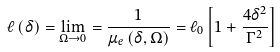Convert formula to latex. <formula><loc_0><loc_0><loc_500><loc_500>\ell \left ( \delta \right ) = \lim _ { \Omega \to 0 } = \frac { 1 } { \mu _ { e } \left ( \delta , \Omega \right ) } = \ell _ { 0 } \left [ 1 + \frac { 4 \delta ^ { 2 } } { \Gamma ^ { 2 } } \right ]</formula> 